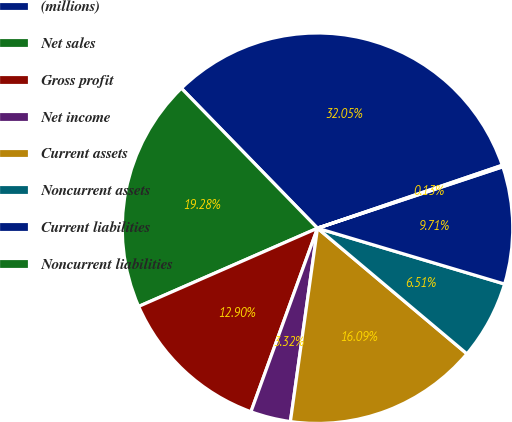<chart> <loc_0><loc_0><loc_500><loc_500><pie_chart><fcel>(millions)<fcel>Net sales<fcel>Gross profit<fcel>Net income<fcel>Current assets<fcel>Noncurrent assets<fcel>Current liabilities<fcel>Noncurrent liabilities<nl><fcel>32.05%<fcel>19.28%<fcel>12.9%<fcel>3.32%<fcel>16.09%<fcel>6.51%<fcel>9.71%<fcel>0.13%<nl></chart> 